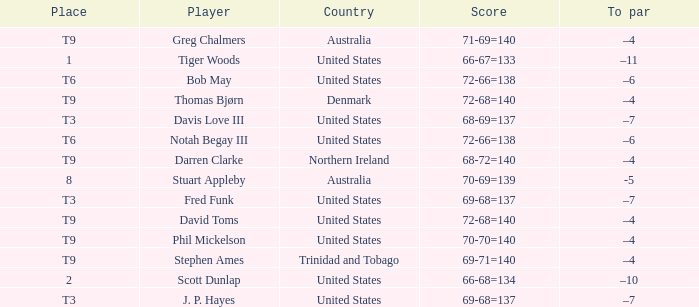What place did Bob May get when his score was 72-66=138? T6. 